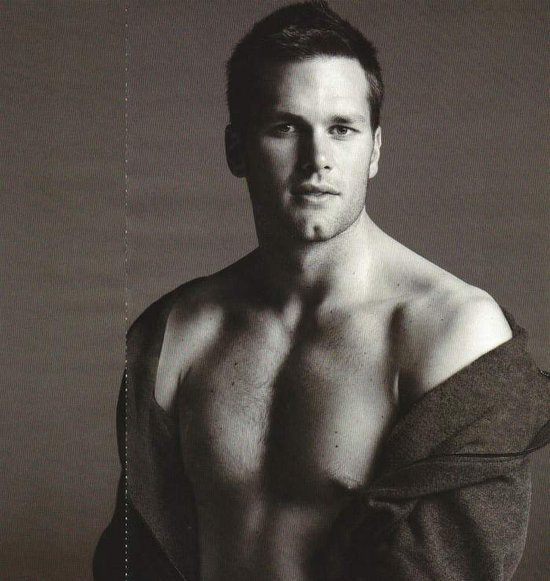Considering the lighting and shadows on the person's face, from which direction is the primary light source coming? The primary light source in the image is emanating from the left side of the subject, or the right side from our perspective as viewers. This can be deduced from the highlights visible on the left side of his face, particularly evident on his cheekbone and jawline, and the subtle shadows cast under his right cheek and neck area. These lighting conditions not only reveal the contour and texture of his facial features but also add a dramatic effect to the overall composition of the portrait. 